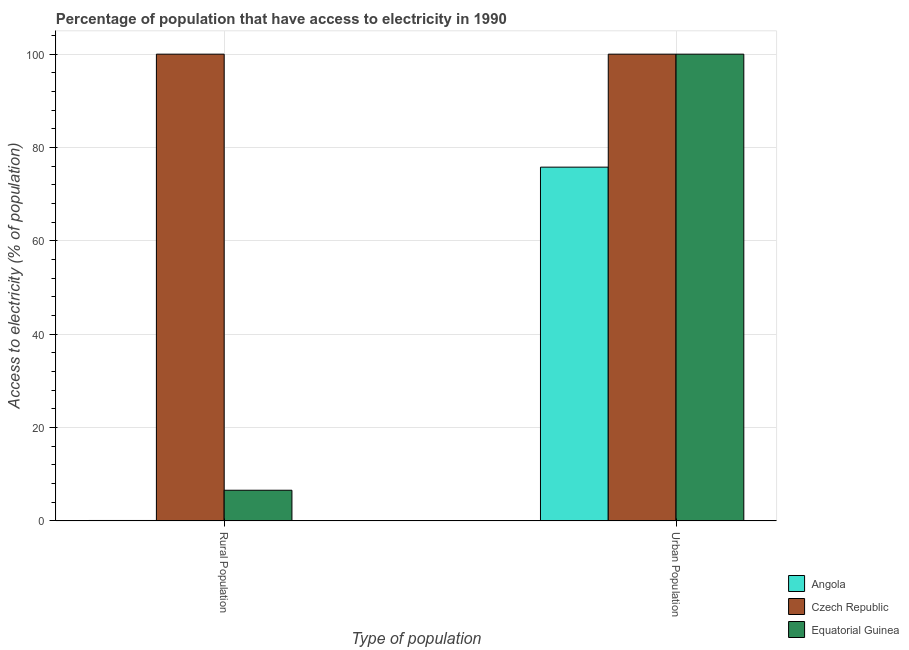How many different coloured bars are there?
Offer a terse response. 3. Are the number of bars per tick equal to the number of legend labels?
Offer a very short reply. Yes. How many bars are there on the 2nd tick from the right?
Provide a short and direct response. 3. What is the label of the 1st group of bars from the left?
Make the answer very short. Rural Population. Across all countries, what is the maximum percentage of urban population having access to electricity?
Your answer should be compact. 100. Across all countries, what is the minimum percentage of urban population having access to electricity?
Offer a terse response. 75.79. In which country was the percentage of rural population having access to electricity maximum?
Your response must be concise. Czech Republic. In which country was the percentage of urban population having access to electricity minimum?
Provide a short and direct response. Angola. What is the total percentage of urban population having access to electricity in the graph?
Provide a succinct answer. 275.79. What is the difference between the percentage of urban population having access to electricity in Equatorial Guinea and that in Angola?
Keep it short and to the point. 24.21. What is the difference between the percentage of urban population having access to electricity in Angola and the percentage of rural population having access to electricity in Czech Republic?
Offer a terse response. -24.21. What is the average percentage of rural population having access to electricity per country?
Offer a terse response. 35.56. What is the difference between the percentage of rural population having access to electricity and percentage of urban population having access to electricity in Equatorial Guinea?
Provide a succinct answer. -93.42. In how many countries, is the percentage of urban population having access to electricity greater than 44 %?
Ensure brevity in your answer.  3. What is the ratio of the percentage of urban population having access to electricity in Angola to that in Equatorial Guinea?
Keep it short and to the point. 0.76. Is the percentage of rural population having access to electricity in Angola less than that in Equatorial Guinea?
Offer a very short reply. Yes. What does the 1st bar from the left in Urban Population represents?
Your answer should be compact. Angola. What does the 1st bar from the right in Urban Population represents?
Offer a terse response. Equatorial Guinea. What is the difference between two consecutive major ticks on the Y-axis?
Offer a terse response. 20. What is the title of the graph?
Offer a terse response. Percentage of population that have access to electricity in 1990. Does "Iraq" appear as one of the legend labels in the graph?
Give a very brief answer. No. What is the label or title of the X-axis?
Give a very brief answer. Type of population. What is the label or title of the Y-axis?
Offer a very short reply. Access to electricity (% of population). What is the Access to electricity (% of population) in Equatorial Guinea in Rural Population?
Your answer should be compact. 6.58. What is the Access to electricity (% of population) in Angola in Urban Population?
Your response must be concise. 75.79. What is the Access to electricity (% of population) in Czech Republic in Urban Population?
Offer a very short reply. 100. What is the Access to electricity (% of population) of Equatorial Guinea in Urban Population?
Your answer should be compact. 100. Across all Type of population, what is the maximum Access to electricity (% of population) in Angola?
Ensure brevity in your answer.  75.79. Across all Type of population, what is the maximum Access to electricity (% of population) of Czech Republic?
Give a very brief answer. 100. Across all Type of population, what is the maximum Access to electricity (% of population) of Equatorial Guinea?
Offer a terse response. 100. Across all Type of population, what is the minimum Access to electricity (% of population) of Equatorial Guinea?
Keep it short and to the point. 6.58. What is the total Access to electricity (% of population) in Angola in the graph?
Your answer should be compact. 75.89. What is the total Access to electricity (% of population) of Czech Republic in the graph?
Offer a terse response. 200. What is the total Access to electricity (% of population) of Equatorial Guinea in the graph?
Ensure brevity in your answer.  106.58. What is the difference between the Access to electricity (% of population) in Angola in Rural Population and that in Urban Population?
Your answer should be very brief. -75.69. What is the difference between the Access to electricity (% of population) of Czech Republic in Rural Population and that in Urban Population?
Your response must be concise. 0. What is the difference between the Access to electricity (% of population) of Equatorial Guinea in Rural Population and that in Urban Population?
Make the answer very short. -93.42. What is the difference between the Access to electricity (% of population) in Angola in Rural Population and the Access to electricity (% of population) in Czech Republic in Urban Population?
Make the answer very short. -99.9. What is the difference between the Access to electricity (% of population) of Angola in Rural Population and the Access to electricity (% of population) of Equatorial Guinea in Urban Population?
Your answer should be compact. -99.9. What is the difference between the Access to electricity (% of population) in Czech Republic in Rural Population and the Access to electricity (% of population) in Equatorial Guinea in Urban Population?
Offer a terse response. 0. What is the average Access to electricity (% of population) of Angola per Type of population?
Give a very brief answer. 37.95. What is the average Access to electricity (% of population) in Czech Republic per Type of population?
Give a very brief answer. 100. What is the average Access to electricity (% of population) in Equatorial Guinea per Type of population?
Your response must be concise. 53.29. What is the difference between the Access to electricity (% of population) in Angola and Access to electricity (% of population) in Czech Republic in Rural Population?
Keep it short and to the point. -99.9. What is the difference between the Access to electricity (% of population) of Angola and Access to electricity (% of population) of Equatorial Guinea in Rural Population?
Keep it short and to the point. -6.48. What is the difference between the Access to electricity (% of population) in Czech Republic and Access to electricity (% of population) in Equatorial Guinea in Rural Population?
Ensure brevity in your answer.  93.42. What is the difference between the Access to electricity (% of population) in Angola and Access to electricity (% of population) in Czech Republic in Urban Population?
Ensure brevity in your answer.  -24.21. What is the difference between the Access to electricity (% of population) in Angola and Access to electricity (% of population) in Equatorial Guinea in Urban Population?
Keep it short and to the point. -24.21. What is the difference between the Access to electricity (% of population) of Czech Republic and Access to electricity (% of population) of Equatorial Guinea in Urban Population?
Ensure brevity in your answer.  0. What is the ratio of the Access to electricity (% of population) in Angola in Rural Population to that in Urban Population?
Your answer should be compact. 0. What is the ratio of the Access to electricity (% of population) of Czech Republic in Rural Population to that in Urban Population?
Offer a terse response. 1. What is the ratio of the Access to electricity (% of population) of Equatorial Guinea in Rural Population to that in Urban Population?
Your answer should be very brief. 0.07. What is the difference between the highest and the second highest Access to electricity (% of population) of Angola?
Provide a succinct answer. 75.69. What is the difference between the highest and the second highest Access to electricity (% of population) in Czech Republic?
Offer a terse response. 0. What is the difference between the highest and the second highest Access to electricity (% of population) of Equatorial Guinea?
Provide a short and direct response. 93.42. What is the difference between the highest and the lowest Access to electricity (% of population) in Angola?
Keep it short and to the point. 75.69. What is the difference between the highest and the lowest Access to electricity (% of population) in Equatorial Guinea?
Your response must be concise. 93.42. 